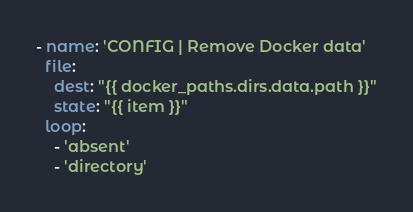<code> <loc_0><loc_0><loc_500><loc_500><_YAML_>- name: 'CONFIG | Remove Docker data'
  file:
    dest: "{{ docker_paths.dirs.data.path }}"
    state: "{{ item }}"
  loop:
    - 'absent'
    - 'directory'
</code> 